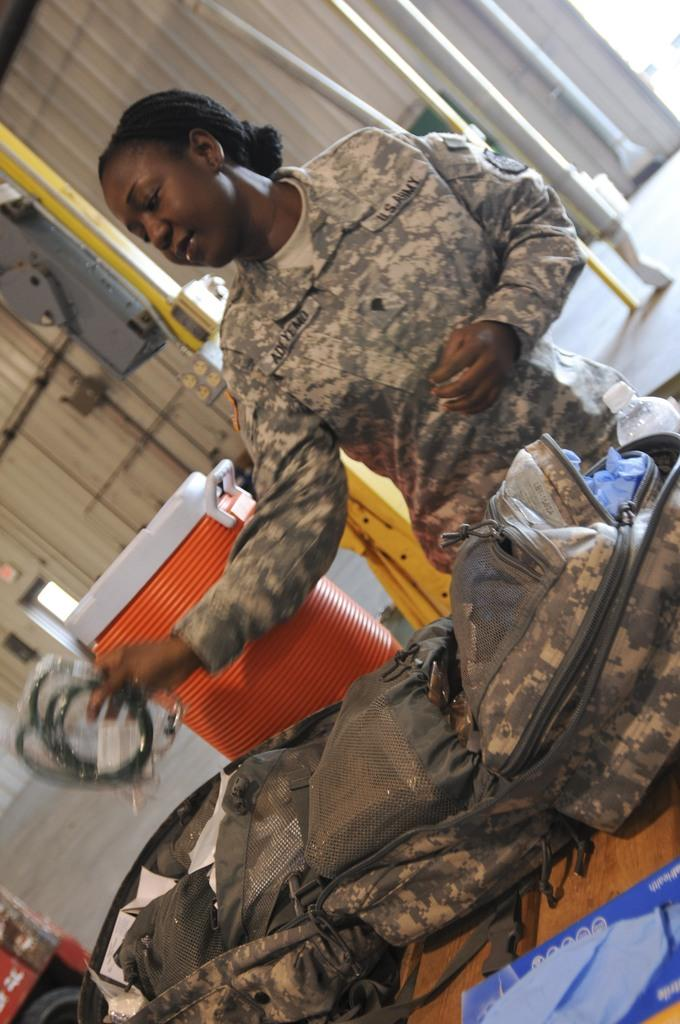What is the occupation of the person in the image? There is a lady soldier in the image. What is the lady soldier doing in the image? The lady soldier is checking a bag. Where is the bag located in the image? The bag is on a table. What can be seen in the background of the image? There is a trash box, poles, and an iron sheet in the background of the image. What type of music is the band playing in the background of the image? There is no band present in the image, so it is not possible to determine what type of music might be playing. 